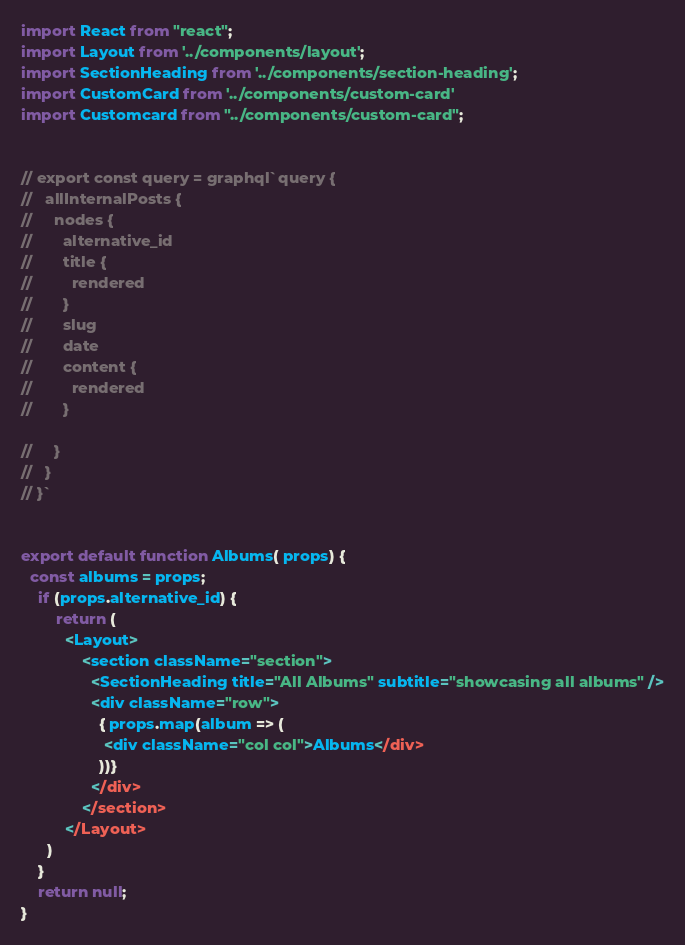Convert code to text. <code><loc_0><loc_0><loc_500><loc_500><_JavaScript_>import React from "react";
import Layout from '../components/layout';
import SectionHeading from '../components/section-heading';
import CustomCard from '../components/custom-card'
import Customcard from "../components/custom-card";


// export const query = graphql`query {
//   allInternalPosts {
//     nodes {
//       alternative_id
//       title {
//         rendered
//       }
//       slug
//       date
//       content {
//         rendered
//       }
      
//     }
//   }
// }`


export default function Albums( props) {
  const albums = props;
    if (props.alternative_id) {
        return (
          <Layout>
              <section className="section">
                <SectionHeading title="All Albums" subtitle="showcasing all albums" />
                <div className="row">
                  { props.map(album => (
                   <div className="col col">Albums</div>
                  ))}
                </div>
              </section>
          </Layout>
      )
    } 
    return null;
}
</code> 